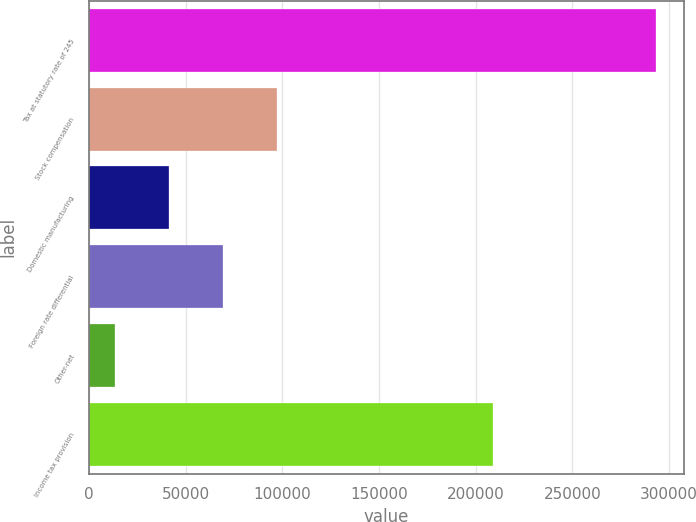Convert chart to OTSL. <chart><loc_0><loc_0><loc_500><loc_500><bar_chart><fcel>Tax at statutory rate of 245<fcel>Stock compensation<fcel>Domestic manufacturing<fcel>Foreign rate differential<fcel>Other-net<fcel>Income tax provision<nl><fcel>293129<fcel>97452.4<fcel>41544.8<fcel>69498.6<fcel>13591<fcel>208889<nl></chart> 